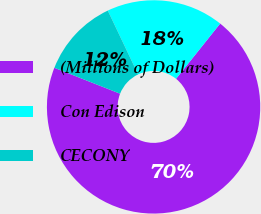Convert chart. <chart><loc_0><loc_0><loc_500><loc_500><pie_chart><fcel>(Millions of Dollars)<fcel>Con Edison<fcel>CECONY<nl><fcel>70.25%<fcel>17.79%<fcel>11.96%<nl></chart> 